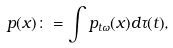Convert formula to latex. <formula><loc_0><loc_0><loc_500><loc_500>p ( x ) \colon = \int { p _ { t \omega } ( x ) d \tau ( t ) } ,</formula> 